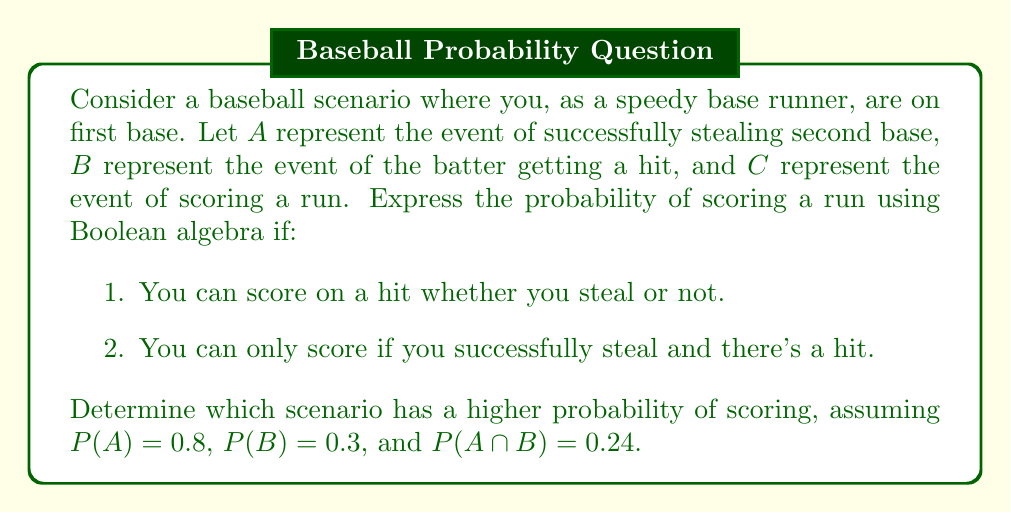Help me with this question. Let's analyze each scenario using Boolean algebra:

1. You can score on a hit whether you steal or not:
   In this case, scoring occurs if there's a hit (B) or if you steal and there's a hit (A ∩ B).
   The Boolean expression is: $C = B \cup (A \cap B)$

   Using the probability formula for union:
   $P(C) = P(B \cup (A \cap B)) = P(B) + P(A \cap B) - P(B \cap (A \cap B))$
   
   Since $B \cap (A \cap B) = A \cap B$, we have:
   $P(C) = P(B) + P(A \cap B) - P(A \cap B) = P(B) = 0.3$

2. You can only score if you successfully steal and there's a hit:
   In this case, scoring occurs only if both events A and B happen.
   The Boolean expression is: $C = A \cap B$

   The probability is simply:
   $P(C) = P(A \cap B) = 0.24$

Comparing the two scenarios:
Scenario 1: $P(C) = 0.3$
Scenario 2: $P(C) = 0.24$

Therefore, scenario 1 has a higher probability of scoring.
Answer: Scenario 1: $P(C) = 0.3$; Scenario 2: $P(C) = 0.24$; Scenario 1 has higher probability. 